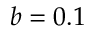<formula> <loc_0><loc_0><loc_500><loc_500>b = 0 . 1</formula> 